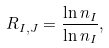<formula> <loc_0><loc_0><loc_500><loc_500>R _ { I , J } = \frac { \ln n _ { I } } { \ln n _ { I } } ,</formula> 